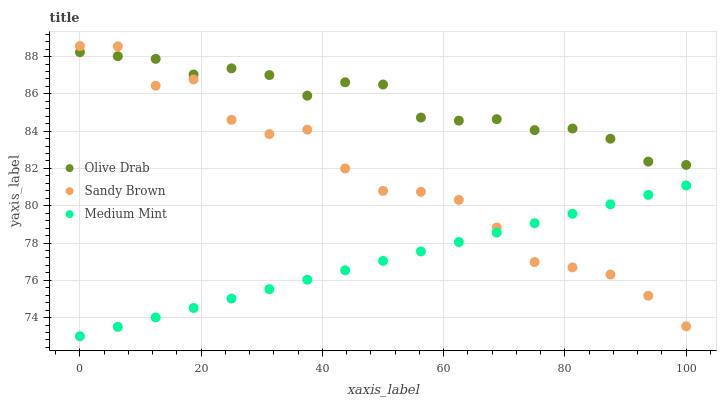Does Medium Mint have the minimum area under the curve?
Answer yes or no. Yes. Does Olive Drab have the maximum area under the curve?
Answer yes or no. Yes. Does Sandy Brown have the minimum area under the curve?
Answer yes or no. No. Does Sandy Brown have the maximum area under the curve?
Answer yes or no. No. Is Medium Mint the smoothest?
Answer yes or no. Yes. Is Sandy Brown the roughest?
Answer yes or no. Yes. Is Olive Drab the smoothest?
Answer yes or no. No. Is Olive Drab the roughest?
Answer yes or no. No. Does Medium Mint have the lowest value?
Answer yes or no. Yes. Does Sandy Brown have the lowest value?
Answer yes or no. No. Does Sandy Brown have the highest value?
Answer yes or no. Yes. Does Olive Drab have the highest value?
Answer yes or no. No. Is Medium Mint less than Olive Drab?
Answer yes or no. Yes. Is Olive Drab greater than Medium Mint?
Answer yes or no. Yes. Does Sandy Brown intersect Olive Drab?
Answer yes or no. Yes. Is Sandy Brown less than Olive Drab?
Answer yes or no. No. Is Sandy Brown greater than Olive Drab?
Answer yes or no. No. Does Medium Mint intersect Olive Drab?
Answer yes or no. No. 